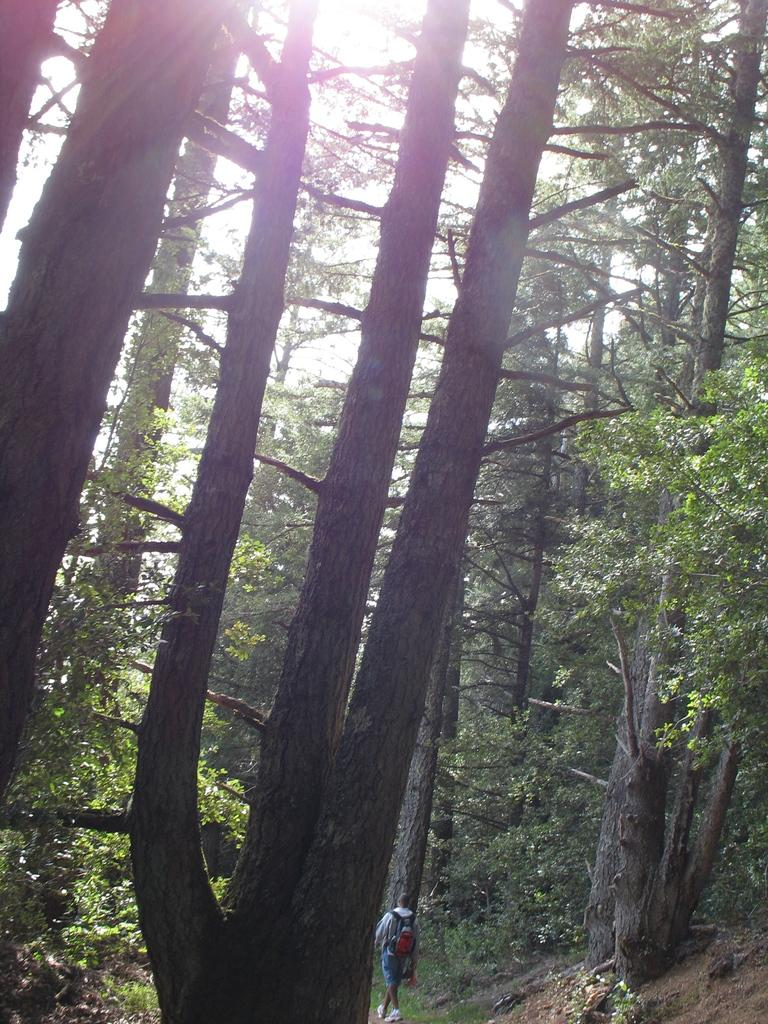What is the main subject of the image? There is a person in the image. What is the person wearing? The person is wearing a backpack. What is the person doing in the image? The person is walking. What type of vegetation can be seen in the image? There are trees and plants in the image. What is the ground covered with in the image? The ground is covered with grass. What is visible at the top of the image? The sky is visible at the top of the image, and sunlight is present in the sky. How many chickens are present in the image? There are no chickens present in the image. What type of son can be seen playing with the person in the image? There is no son present in the image, and the person is walking alone. 